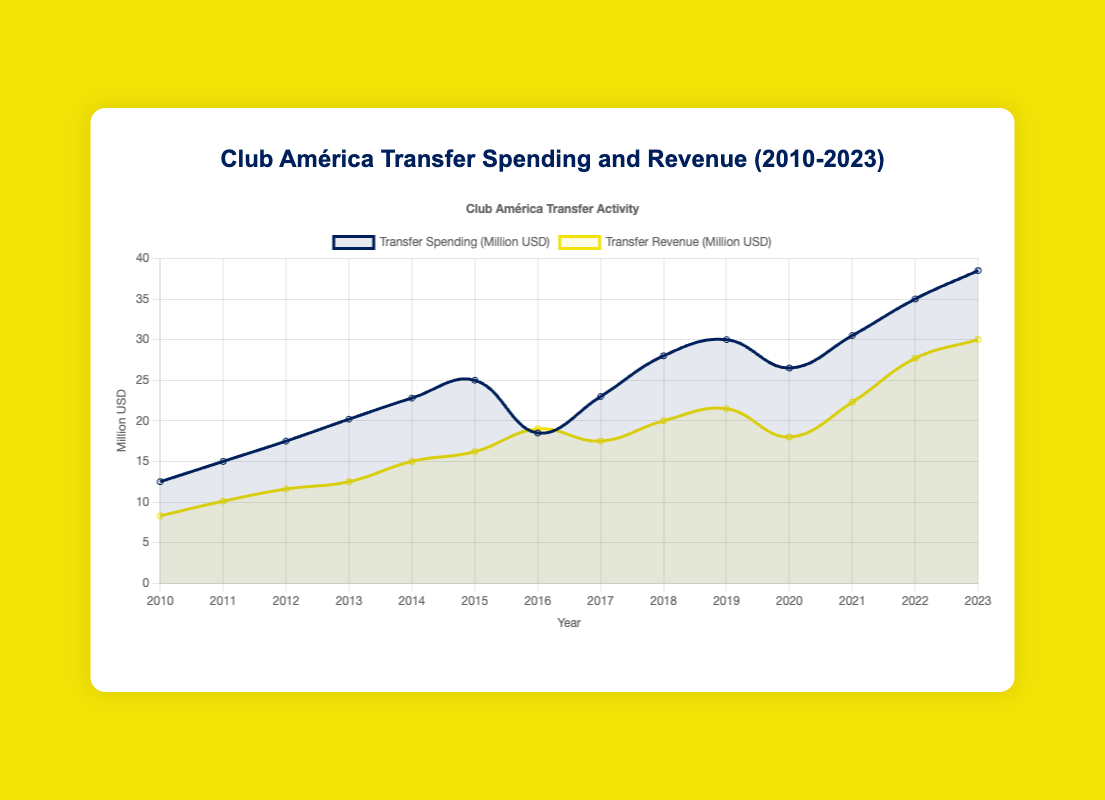what is the highest transfer spending year and amount? By examining the highest point on the transfer spending curve, we can identify the year 2023 as having the highest spending of 38.5 million USD.
Answer: 2023, 38.5 million USD In which year did Club América have the highest transfer revenue? By locating the highest point in the transfer revenue curve, we can identify the year 2023 as having the highest revenue of 30 million USD.
Answer: 2023, 30 million USD What is the difference between transfer spending and revenue in 2016? In 2016, transfer spending is 18.5 million USD and transfer revenue is 19.0 million USD. The difference is calculated as 19.0 - 18.5 = 0.5 million USD.
Answer: 0.5 million USD Which year has the largest negative difference between transfer spending and revenue? The largest negative difference can be determined by calculating the difference for each year and identifying the greatest negative value. In 2020, the spending was 26.5 million USD and the revenue was 18.0 million USD, resulting in a difference of 26.5 - 18.0 = 8.5 million USD.
Answer: 2020 What was the average transfer spending between 2010 and 2015? The average is calculated by summing the transfer spending from 2010 to 2015 (12.5 + 15.0 + 17.5 + 20.2 + 22.8 + 25.0), which equals 113.0, and then dividing by 6 years. Thus, the average is 113.0 / 6 = 18.833 million USD.
Answer: 18.833 million USD Identify the year when the transfer spending started consistently increasing after 2016. By observing the curve, the transfer spending increases every year after 2016, starting from 2017.
Answer: 2017 In which year did Club América's transfer revenue surpass 20 million USD for the first time? By examining the transfer revenue curve, we notice that it first surpasses 20 million USD in 2018.
Answer: 2018 What is the cumulative transfer spending from 2018 to 2023? The cumulative spending is calculated by summing the amounts from 2018 to 2023 (28 + 30 + 26.5 + 30.5 + 35 + 38.5), which equals 188.5 million USD.
Answer: 188.5 million USD Compare the transfer spending in 2010 and 2020. Which year had higher spending and by how much? The transfer spending in 2010 was 12.5 million USD and in 2020 was 26.5 million USD. The difference is 26.5 - 12.5 = 14.0 million USD. Therefore, 2020 had higher spending by 14.0 million USD.
Answer: 2020, 14.0 million USD What is the trend of transfer revenue from 2010 to 2023? The transfer revenue shows a generally upward trend from 2010 (8.3 million USD) to 2023 (30.0 million USD), with some fluctuations in between.
Answer: Upward trend 